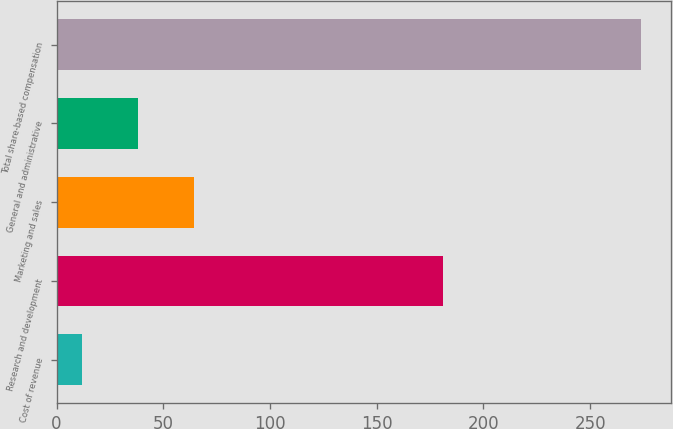Convert chart. <chart><loc_0><loc_0><loc_500><loc_500><bar_chart><fcel>Cost of revenue<fcel>Research and development<fcel>Marketing and sales<fcel>General and administrative<fcel>Total share-based compensation<nl><fcel>12<fcel>181<fcel>64.4<fcel>38.2<fcel>274<nl></chart> 